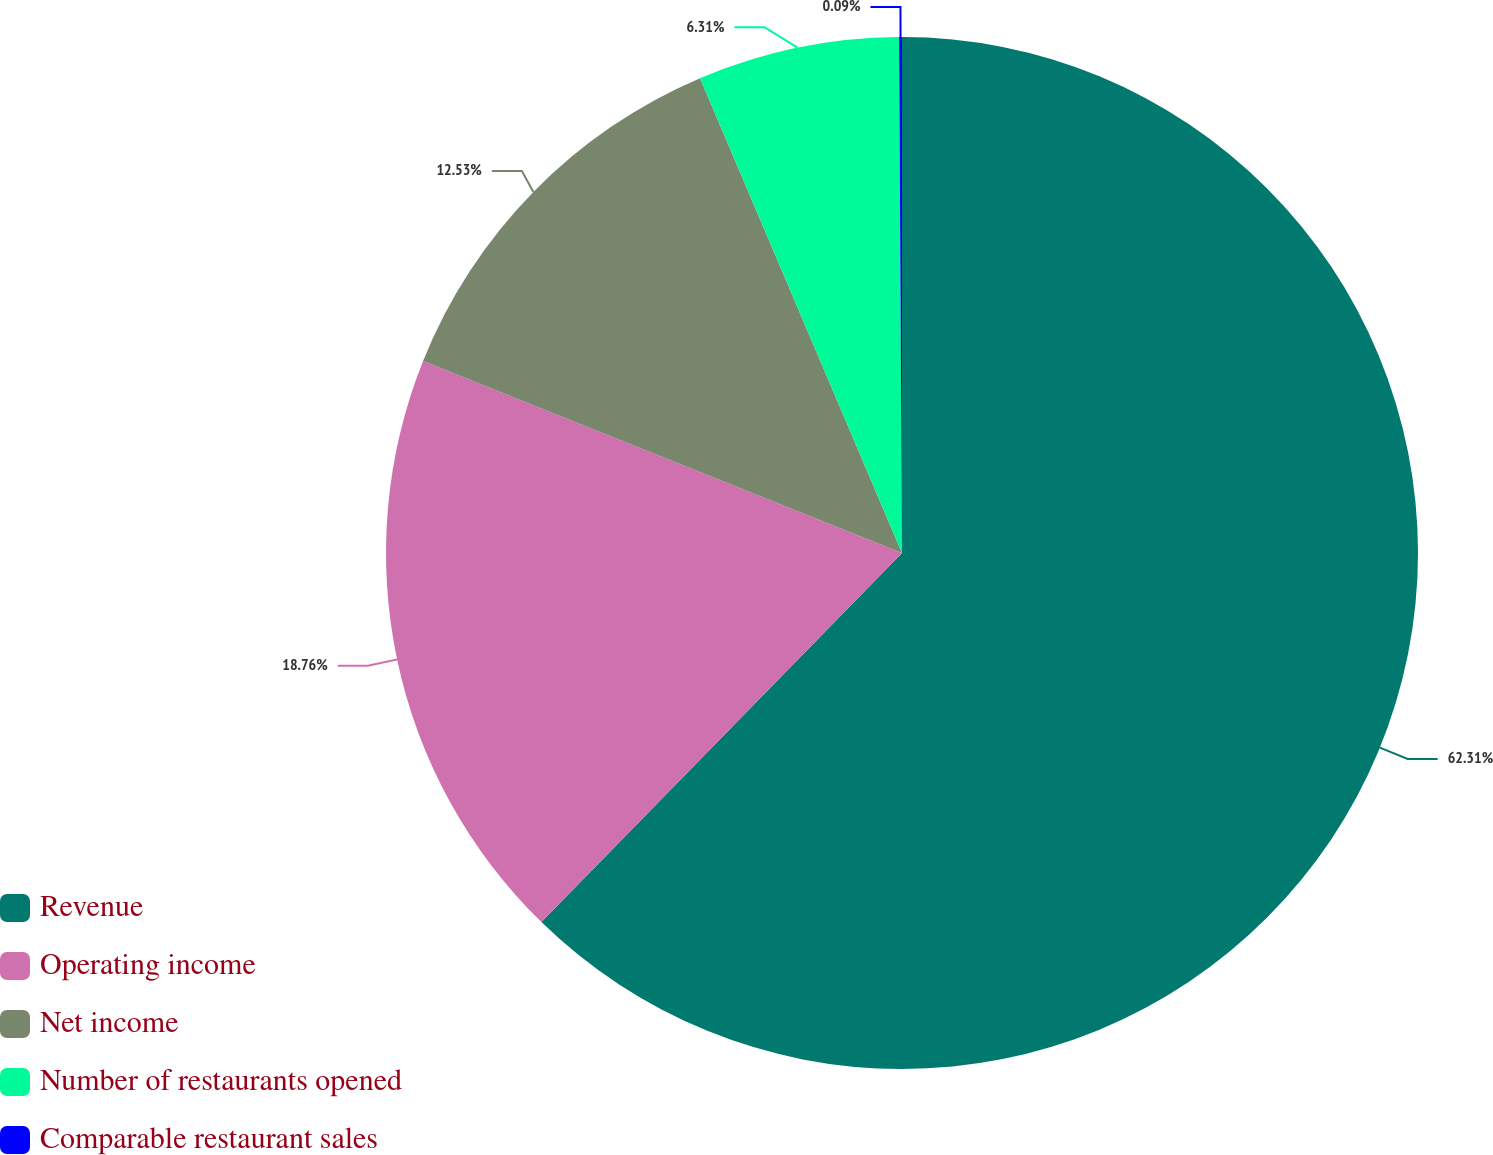Convert chart to OTSL. <chart><loc_0><loc_0><loc_500><loc_500><pie_chart><fcel>Revenue<fcel>Operating income<fcel>Net income<fcel>Number of restaurants opened<fcel>Comparable restaurant sales<nl><fcel>62.32%<fcel>18.76%<fcel>12.53%<fcel>6.31%<fcel>0.09%<nl></chart> 